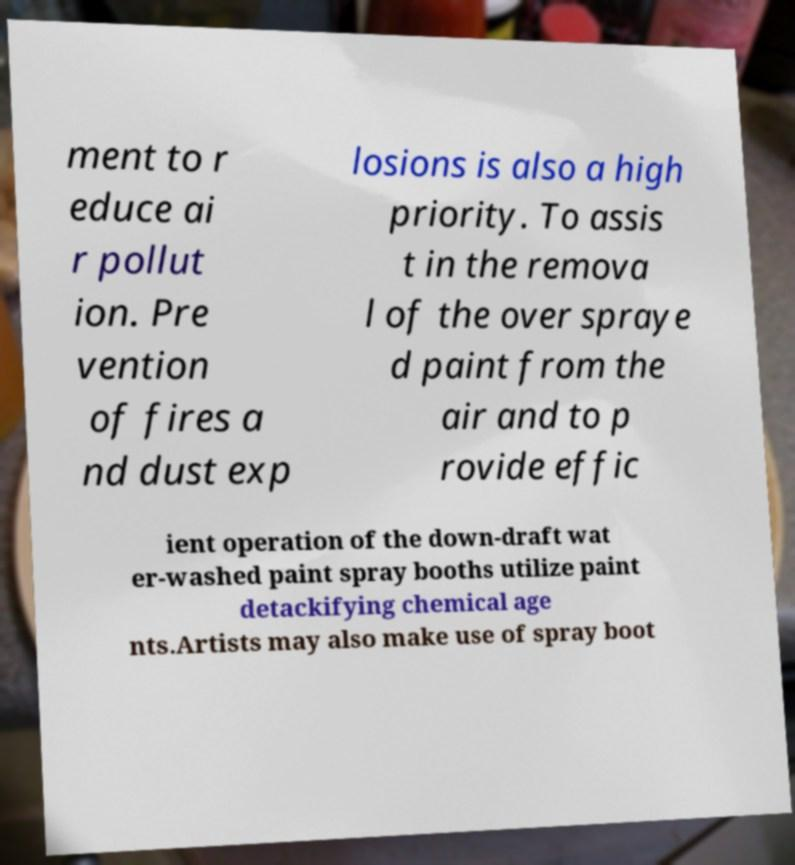Can you read and provide the text displayed in the image?This photo seems to have some interesting text. Can you extract and type it out for me? ment to r educe ai r pollut ion. Pre vention of fires a nd dust exp losions is also a high priority. To assis t in the remova l of the over spraye d paint from the air and to p rovide effic ient operation of the down-draft wat er-washed paint spray booths utilize paint detackifying chemical age nts.Artists may also make use of spray boot 